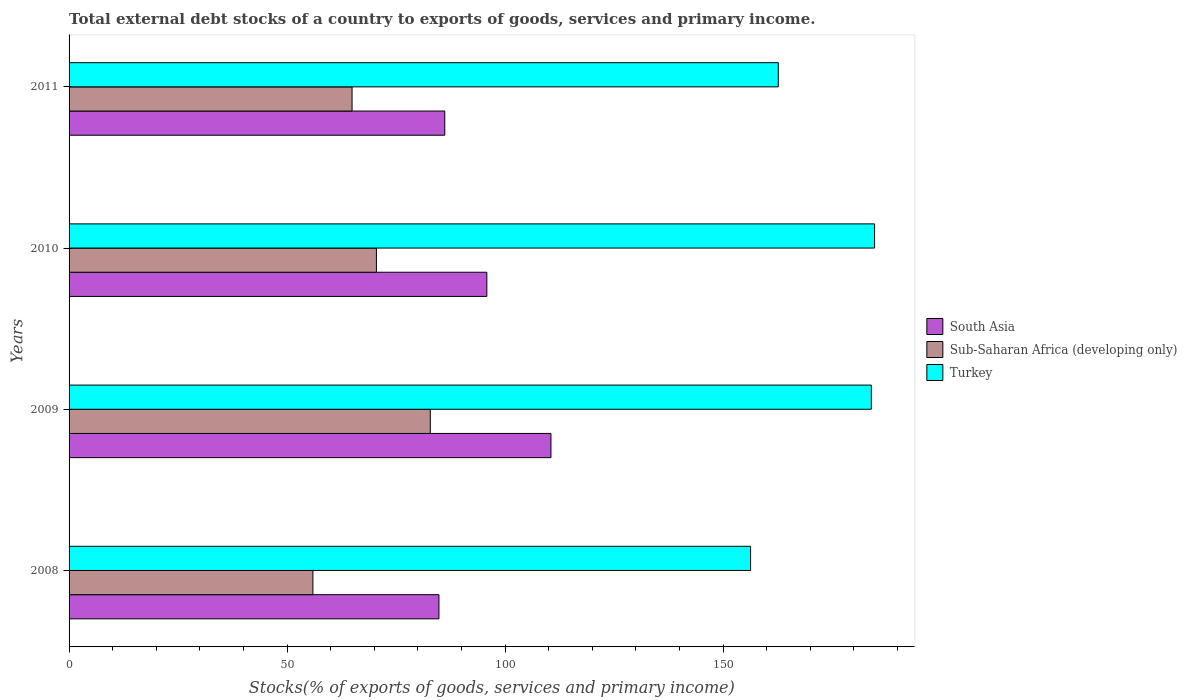How many different coloured bars are there?
Keep it short and to the point. 3. Are the number of bars per tick equal to the number of legend labels?
Keep it short and to the point. Yes. In how many cases, is the number of bars for a given year not equal to the number of legend labels?
Keep it short and to the point. 0. What is the total debt stocks in Sub-Saharan Africa (developing only) in 2010?
Give a very brief answer. 70.49. Across all years, what is the maximum total debt stocks in Turkey?
Make the answer very short. 184.73. Across all years, what is the minimum total debt stocks in Sub-Saharan Africa (developing only)?
Provide a short and direct response. 55.92. In which year was the total debt stocks in Sub-Saharan Africa (developing only) minimum?
Your answer should be very brief. 2008. What is the total total debt stocks in Sub-Saharan Africa (developing only) in the graph?
Your answer should be very brief. 274.14. What is the difference between the total debt stocks in South Asia in 2008 and that in 2010?
Make the answer very short. -10.99. What is the difference between the total debt stocks in Sub-Saharan Africa (developing only) in 2010 and the total debt stocks in South Asia in 2011?
Offer a terse response. -15.68. What is the average total debt stocks in Sub-Saharan Africa (developing only) per year?
Provide a succinct answer. 68.54. In the year 2011, what is the difference between the total debt stocks in South Asia and total debt stocks in Sub-Saharan Africa (developing only)?
Your answer should be very brief. 21.26. What is the ratio of the total debt stocks in Sub-Saharan Africa (developing only) in 2008 to that in 2010?
Your response must be concise. 0.79. Is the total debt stocks in South Asia in 2008 less than that in 2010?
Provide a short and direct response. Yes. What is the difference between the highest and the second highest total debt stocks in South Asia?
Provide a short and direct response. 14.7. What is the difference between the highest and the lowest total debt stocks in Sub-Saharan Africa (developing only)?
Your answer should be very brief. 26.92. Is the sum of the total debt stocks in South Asia in 2010 and 2011 greater than the maximum total debt stocks in Turkey across all years?
Make the answer very short. No. How many years are there in the graph?
Make the answer very short. 4. What is the difference between two consecutive major ticks on the X-axis?
Offer a very short reply. 50. Are the values on the major ticks of X-axis written in scientific E-notation?
Provide a succinct answer. No. Where does the legend appear in the graph?
Provide a succinct answer. Center right. What is the title of the graph?
Your answer should be compact. Total external debt stocks of a country to exports of goods, services and primary income. What is the label or title of the X-axis?
Offer a very short reply. Stocks(% of exports of goods, services and primary income). What is the label or title of the Y-axis?
Give a very brief answer. Years. What is the Stocks(% of exports of goods, services and primary income) of South Asia in 2008?
Offer a very short reply. 84.82. What is the Stocks(% of exports of goods, services and primary income) of Sub-Saharan Africa (developing only) in 2008?
Offer a very short reply. 55.92. What is the Stocks(% of exports of goods, services and primary income) of Turkey in 2008?
Keep it short and to the point. 156.29. What is the Stocks(% of exports of goods, services and primary income) in South Asia in 2009?
Your answer should be compact. 110.51. What is the Stocks(% of exports of goods, services and primary income) in Sub-Saharan Africa (developing only) in 2009?
Your answer should be compact. 82.84. What is the Stocks(% of exports of goods, services and primary income) in Turkey in 2009?
Ensure brevity in your answer.  183.98. What is the Stocks(% of exports of goods, services and primary income) in South Asia in 2010?
Ensure brevity in your answer.  95.81. What is the Stocks(% of exports of goods, services and primary income) in Sub-Saharan Africa (developing only) in 2010?
Give a very brief answer. 70.49. What is the Stocks(% of exports of goods, services and primary income) in Turkey in 2010?
Your answer should be compact. 184.73. What is the Stocks(% of exports of goods, services and primary income) of South Asia in 2011?
Your answer should be very brief. 86.16. What is the Stocks(% of exports of goods, services and primary income) of Sub-Saharan Africa (developing only) in 2011?
Provide a succinct answer. 64.9. What is the Stocks(% of exports of goods, services and primary income) in Turkey in 2011?
Keep it short and to the point. 162.65. Across all years, what is the maximum Stocks(% of exports of goods, services and primary income) of South Asia?
Provide a succinct answer. 110.51. Across all years, what is the maximum Stocks(% of exports of goods, services and primary income) of Sub-Saharan Africa (developing only)?
Your answer should be compact. 82.84. Across all years, what is the maximum Stocks(% of exports of goods, services and primary income) in Turkey?
Your response must be concise. 184.73. Across all years, what is the minimum Stocks(% of exports of goods, services and primary income) of South Asia?
Offer a very short reply. 84.82. Across all years, what is the minimum Stocks(% of exports of goods, services and primary income) of Sub-Saharan Africa (developing only)?
Offer a very short reply. 55.92. Across all years, what is the minimum Stocks(% of exports of goods, services and primary income) of Turkey?
Give a very brief answer. 156.29. What is the total Stocks(% of exports of goods, services and primary income) in South Asia in the graph?
Provide a succinct answer. 377.31. What is the total Stocks(% of exports of goods, services and primary income) in Sub-Saharan Africa (developing only) in the graph?
Give a very brief answer. 274.14. What is the total Stocks(% of exports of goods, services and primary income) of Turkey in the graph?
Offer a terse response. 687.65. What is the difference between the Stocks(% of exports of goods, services and primary income) in South Asia in 2008 and that in 2009?
Offer a very short reply. -25.69. What is the difference between the Stocks(% of exports of goods, services and primary income) of Sub-Saharan Africa (developing only) in 2008 and that in 2009?
Ensure brevity in your answer.  -26.92. What is the difference between the Stocks(% of exports of goods, services and primary income) in Turkey in 2008 and that in 2009?
Your response must be concise. -27.69. What is the difference between the Stocks(% of exports of goods, services and primary income) of South Asia in 2008 and that in 2010?
Your response must be concise. -10.99. What is the difference between the Stocks(% of exports of goods, services and primary income) of Sub-Saharan Africa (developing only) in 2008 and that in 2010?
Your answer should be compact. -14.56. What is the difference between the Stocks(% of exports of goods, services and primary income) of Turkey in 2008 and that in 2010?
Your answer should be very brief. -28.43. What is the difference between the Stocks(% of exports of goods, services and primary income) in South Asia in 2008 and that in 2011?
Give a very brief answer. -1.34. What is the difference between the Stocks(% of exports of goods, services and primary income) of Sub-Saharan Africa (developing only) in 2008 and that in 2011?
Your answer should be compact. -8.98. What is the difference between the Stocks(% of exports of goods, services and primary income) in Turkey in 2008 and that in 2011?
Offer a terse response. -6.36. What is the difference between the Stocks(% of exports of goods, services and primary income) in South Asia in 2009 and that in 2010?
Your answer should be very brief. 14.7. What is the difference between the Stocks(% of exports of goods, services and primary income) of Sub-Saharan Africa (developing only) in 2009 and that in 2010?
Offer a very short reply. 12.35. What is the difference between the Stocks(% of exports of goods, services and primary income) of Turkey in 2009 and that in 2010?
Keep it short and to the point. -0.74. What is the difference between the Stocks(% of exports of goods, services and primary income) of South Asia in 2009 and that in 2011?
Make the answer very short. 24.35. What is the difference between the Stocks(% of exports of goods, services and primary income) of Sub-Saharan Africa (developing only) in 2009 and that in 2011?
Make the answer very short. 17.94. What is the difference between the Stocks(% of exports of goods, services and primary income) of Turkey in 2009 and that in 2011?
Your answer should be compact. 21.33. What is the difference between the Stocks(% of exports of goods, services and primary income) of South Asia in 2010 and that in 2011?
Offer a very short reply. 9.65. What is the difference between the Stocks(% of exports of goods, services and primary income) in Sub-Saharan Africa (developing only) in 2010 and that in 2011?
Keep it short and to the point. 5.59. What is the difference between the Stocks(% of exports of goods, services and primary income) of Turkey in 2010 and that in 2011?
Your answer should be very brief. 22.08. What is the difference between the Stocks(% of exports of goods, services and primary income) in South Asia in 2008 and the Stocks(% of exports of goods, services and primary income) in Sub-Saharan Africa (developing only) in 2009?
Ensure brevity in your answer.  1.98. What is the difference between the Stocks(% of exports of goods, services and primary income) of South Asia in 2008 and the Stocks(% of exports of goods, services and primary income) of Turkey in 2009?
Make the answer very short. -99.16. What is the difference between the Stocks(% of exports of goods, services and primary income) in Sub-Saharan Africa (developing only) in 2008 and the Stocks(% of exports of goods, services and primary income) in Turkey in 2009?
Your answer should be very brief. -128.06. What is the difference between the Stocks(% of exports of goods, services and primary income) in South Asia in 2008 and the Stocks(% of exports of goods, services and primary income) in Sub-Saharan Africa (developing only) in 2010?
Keep it short and to the point. 14.34. What is the difference between the Stocks(% of exports of goods, services and primary income) in South Asia in 2008 and the Stocks(% of exports of goods, services and primary income) in Turkey in 2010?
Your answer should be very brief. -99.9. What is the difference between the Stocks(% of exports of goods, services and primary income) in Sub-Saharan Africa (developing only) in 2008 and the Stocks(% of exports of goods, services and primary income) in Turkey in 2010?
Your response must be concise. -128.8. What is the difference between the Stocks(% of exports of goods, services and primary income) of South Asia in 2008 and the Stocks(% of exports of goods, services and primary income) of Sub-Saharan Africa (developing only) in 2011?
Offer a very short reply. 19.92. What is the difference between the Stocks(% of exports of goods, services and primary income) in South Asia in 2008 and the Stocks(% of exports of goods, services and primary income) in Turkey in 2011?
Make the answer very short. -77.83. What is the difference between the Stocks(% of exports of goods, services and primary income) in Sub-Saharan Africa (developing only) in 2008 and the Stocks(% of exports of goods, services and primary income) in Turkey in 2011?
Your answer should be very brief. -106.73. What is the difference between the Stocks(% of exports of goods, services and primary income) in South Asia in 2009 and the Stocks(% of exports of goods, services and primary income) in Sub-Saharan Africa (developing only) in 2010?
Make the answer very short. 40.03. What is the difference between the Stocks(% of exports of goods, services and primary income) of South Asia in 2009 and the Stocks(% of exports of goods, services and primary income) of Turkey in 2010?
Provide a succinct answer. -74.21. What is the difference between the Stocks(% of exports of goods, services and primary income) in Sub-Saharan Africa (developing only) in 2009 and the Stocks(% of exports of goods, services and primary income) in Turkey in 2010?
Provide a short and direct response. -101.89. What is the difference between the Stocks(% of exports of goods, services and primary income) in South Asia in 2009 and the Stocks(% of exports of goods, services and primary income) in Sub-Saharan Africa (developing only) in 2011?
Provide a succinct answer. 45.61. What is the difference between the Stocks(% of exports of goods, services and primary income) of South Asia in 2009 and the Stocks(% of exports of goods, services and primary income) of Turkey in 2011?
Offer a terse response. -52.14. What is the difference between the Stocks(% of exports of goods, services and primary income) in Sub-Saharan Africa (developing only) in 2009 and the Stocks(% of exports of goods, services and primary income) in Turkey in 2011?
Ensure brevity in your answer.  -79.81. What is the difference between the Stocks(% of exports of goods, services and primary income) in South Asia in 2010 and the Stocks(% of exports of goods, services and primary income) in Sub-Saharan Africa (developing only) in 2011?
Provide a short and direct response. 30.91. What is the difference between the Stocks(% of exports of goods, services and primary income) of South Asia in 2010 and the Stocks(% of exports of goods, services and primary income) of Turkey in 2011?
Ensure brevity in your answer.  -66.84. What is the difference between the Stocks(% of exports of goods, services and primary income) of Sub-Saharan Africa (developing only) in 2010 and the Stocks(% of exports of goods, services and primary income) of Turkey in 2011?
Keep it short and to the point. -92.17. What is the average Stocks(% of exports of goods, services and primary income) of South Asia per year?
Your answer should be compact. 94.33. What is the average Stocks(% of exports of goods, services and primary income) in Sub-Saharan Africa (developing only) per year?
Ensure brevity in your answer.  68.54. What is the average Stocks(% of exports of goods, services and primary income) of Turkey per year?
Ensure brevity in your answer.  171.91. In the year 2008, what is the difference between the Stocks(% of exports of goods, services and primary income) in South Asia and Stocks(% of exports of goods, services and primary income) in Sub-Saharan Africa (developing only)?
Offer a terse response. 28.9. In the year 2008, what is the difference between the Stocks(% of exports of goods, services and primary income) in South Asia and Stocks(% of exports of goods, services and primary income) in Turkey?
Your response must be concise. -71.47. In the year 2008, what is the difference between the Stocks(% of exports of goods, services and primary income) of Sub-Saharan Africa (developing only) and Stocks(% of exports of goods, services and primary income) of Turkey?
Your answer should be compact. -100.37. In the year 2009, what is the difference between the Stocks(% of exports of goods, services and primary income) of South Asia and Stocks(% of exports of goods, services and primary income) of Sub-Saharan Africa (developing only)?
Provide a succinct answer. 27.67. In the year 2009, what is the difference between the Stocks(% of exports of goods, services and primary income) in South Asia and Stocks(% of exports of goods, services and primary income) in Turkey?
Give a very brief answer. -73.47. In the year 2009, what is the difference between the Stocks(% of exports of goods, services and primary income) of Sub-Saharan Africa (developing only) and Stocks(% of exports of goods, services and primary income) of Turkey?
Your answer should be very brief. -101.14. In the year 2010, what is the difference between the Stocks(% of exports of goods, services and primary income) in South Asia and Stocks(% of exports of goods, services and primary income) in Sub-Saharan Africa (developing only)?
Provide a short and direct response. 25.33. In the year 2010, what is the difference between the Stocks(% of exports of goods, services and primary income) in South Asia and Stocks(% of exports of goods, services and primary income) in Turkey?
Offer a very short reply. -88.92. In the year 2010, what is the difference between the Stocks(% of exports of goods, services and primary income) in Sub-Saharan Africa (developing only) and Stocks(% of exports of goods, services and primary income) in Turkey?
Provide a short and direct response. -114.24. In the year 2011, what is the difference between the Stocks(% of exports of goods, services and primary income) in South Asia and Stocks(% of exports of goods, services and primary income) in Sub-Saharan Africa (developing only)?
Offer a very short reply. 21.26. In the year 2011, what is the difference between the Stocks(% of exports of goods, services and primary income) in South Asia and Stocks(% of exports of goods, services and primary income) in Turkey?
Keep it short and to the point. -76.49. In the year 2011, what is the difference between the Stocks(% of exports of goods, services and primary income) of Sub-Saharan Africa (developing only) and Stocks(% of exports of goods, services and primary income) of Turkey?
Make the answer very short. -97.75. What is the ratio of the Stocks(% of exports of goods, services and primary income) in South Asia in 2008 to that in 2009?
Your response must be concise. 0.77. What is the ratio of the Stocks(% of exports of goods, services and primary income) in Sub-Saharan Africa (developing only) in 2008 to that in 2009?
Keep it short and to the point. 0.68. What is the ratio of the Stocks(% of exports of goods, services and primary income) in Turkey in 2008 to that in 2009?
Ensure brevity in your answer.  0.85. What is the ratio of the Stocks(% of exports of goods, services and primary income) of South Asia in 2008 to that in 2010?
Your answer should be compact. 0.89. What is the ratio of the Stocks(% of exports of goods, services and primary income) in Sub-Saharan Africa (developing only) in 2008 to that in 2010?
Your response must be concise. 0.79. What is the ratio of the Stocks(% of exports of goods, services and primary income) in Turkey in 2008 to that in 2010?
Make the answer very short. 0.85. What is the ratio of the Stocks(% of exports of goods, services and primary income) in South Asia in 2008 to that in 2011?
Your response must be concise. 0.98. What is the ratio of the Stocks(% of exports of goods, services and primary income) in Sub-Saharan Africa (developing only) in 2008 to that in 2011?
Provide a short and direct response. 0.86. What is the ratio of the Stocks(% of exports of goods, services and primary income) of Turkey in 2008 to that in 2011?
Provide a short and direct response. 0.96. What is the ratio of the Stocks(% of exports of goods, services and primary income) in South Asia in 2009 to that in 2010?
Keep it short and to the point. 1.15. What is the ratio of the Stocks(% of exports of goods, services and primary income) in Sub-Saharan Africa (developing only) in 2009 to that in 2010?
Your answer should be very brief. 1.18. What is the ratio of the Stocks(% of exports of goods, services and primary income) of Turkey in 2009 to that in 2010?
Offer a very short reply. 1. What is the ratio of the Stocks(% of exports of goods, services and primary income) of South Asia in 2009 to that in 2011?
Offer a terse response. 1.28. What is the ratio of the Stocks(% of exports of goods, services and primary income) of Sub-Saharan Africa (developing only) in 2009 to that in 2011?
Your answer should be very brief. 1.28. What is the ratio of the Stocks(% of exports of goods, services and primary income) of Turkey in 2009 to that in 2011?
Your answer should be very brief. 1.13. What is the ratio of the Stocks(% of exports of goods, services and primary income) in South Asia in 2010 to that in 2011?
Your answer should be compact. 1.11. What is the ratio of the Stocks(% of exports of goods, services and primary income) in Sub-Saharan Africa (developing only) in 2010 to that in 2011?
Give a very brief answer. 1.09. What is the ratio of the Stocks(% of exports of goods, services and primary income) of Turkey in 2010 to that in 2011?
Provide a succinct answer. 1.14. What is the difference between the highest and the second highest Stocks(% of exports of goods, services and primary income) of South Asia?
Offer a very short reply. 14.7. What is the difference between the highest and the second highest Stocks(% of exports of goods, services and primary income) in Sub-Saharan Africa (developing only)?
Keep it short and to the point. 12.35. What is the difference between the highest and the second highest Stocks(% of exports of goods, services and primary income) of Turkey?
Offer a terse response. 0.74. What is the difference between the highest and the lowest Stocks(% of exports of goods, services and primary income) of South Asia?
Your response must be concise. 25.69. What is the difference between the highest and the lowest Stocks(% of exports of goods, services and primary income) of Sub-Saharan Africa (developing only)?
Offer a very short reply. 26.92. What is the difference between the highest and the lowest Stocks(% of exports of goods, services and primary income) in Turkey?
Your response must be concise. 28.43. 